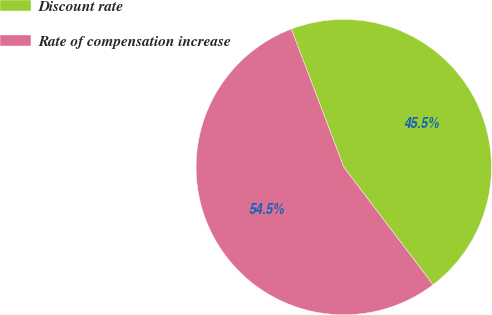Convert chart. <chart><loc_0><loc_0><loc_500><loc_500><pie_chart><fcel>Discount rate<fcel>Rate of compensation increase<nl><fcel>45.45%<fcel>54.55%<nl></chart> 